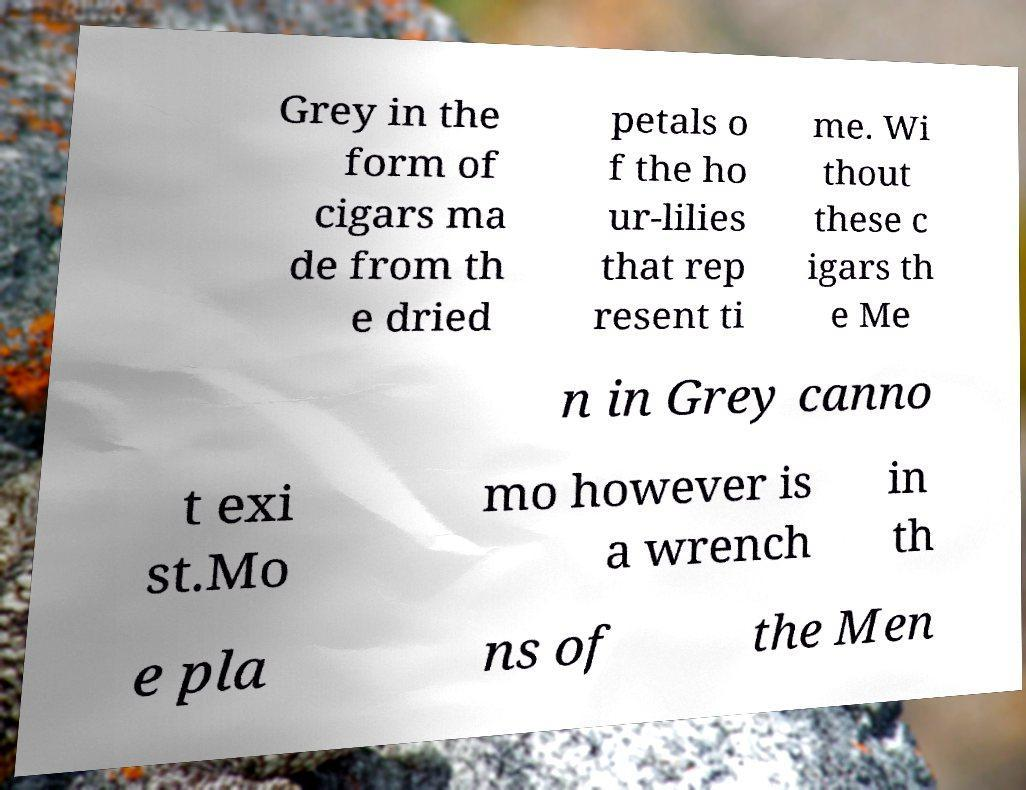There's text embedded in this image that I need extracted. Can you transcribe it verbatim? Grey in the form of cigars ma de from th e dried petals o f the ho ur-lilies that rep resent ti me. Wi thout these c igars th e Me n in Grey canno t exi st.Mo mo however is a wrench in th e pla ns of the Men 